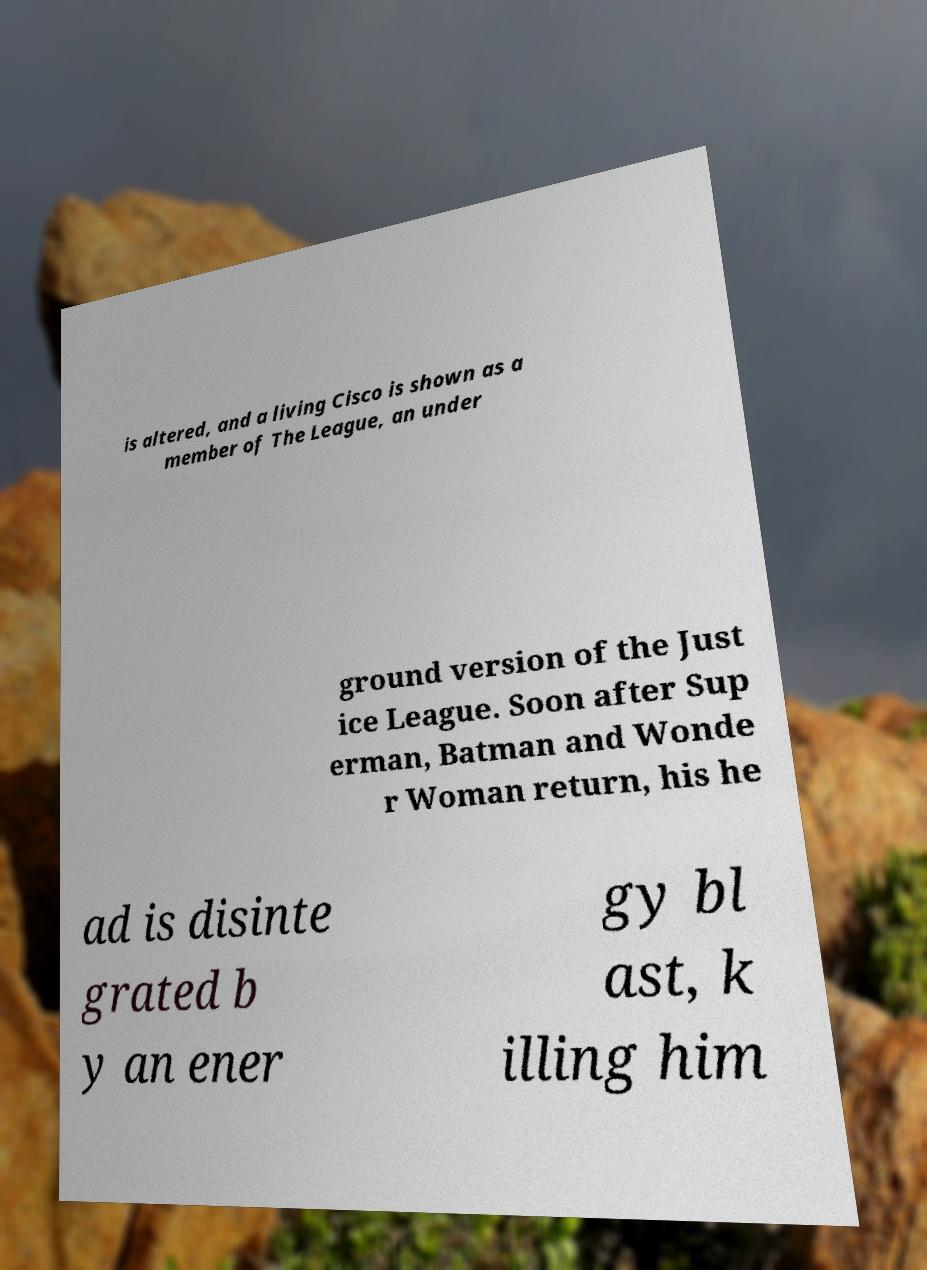Could you extract and type out the text from this image? is altered, and a living Cisco is shown as a member of The League, an under ground version of the Just ice League. Soon after Sup erman, Batman and Wonde r Woman return, his he ad is disinte grated b y an ener gy bl ast, k illing him 